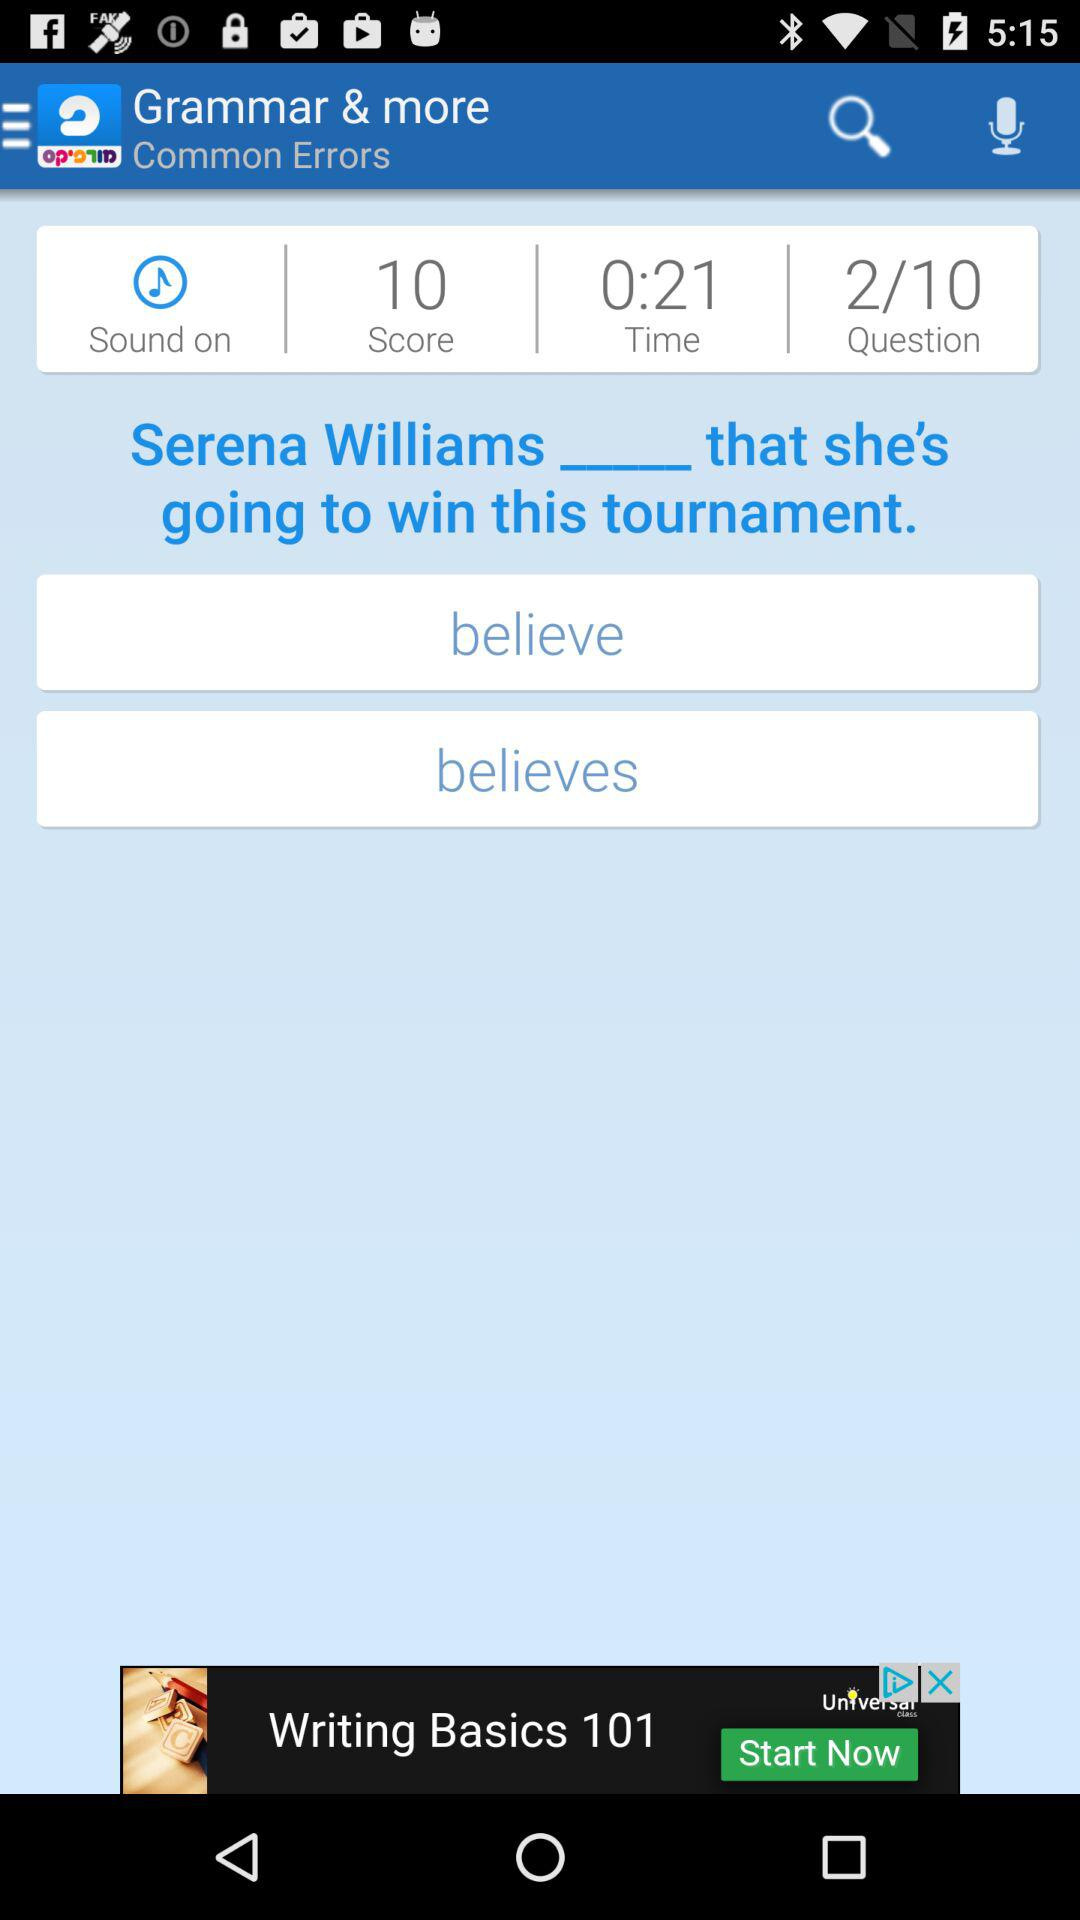Who is answering the grammar questions?
When the provided information is insufficient, respond with <no answer>. <no answer> 